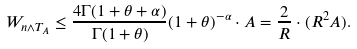<formula> <loc_0><loc_0><loc_500><loc_500>W _ { n \wedge T _ { A } } & \leq \frac { 4 \Gamma ( 1 + \theta + \alpha ) } { \Gamma ( 1 + \theta ) } ( 1 + \theta ) ^ { - \alpha } \cdot A = \frac { 2 } { R } \cdot ( R ^ { 2 } A ) .</formula> 